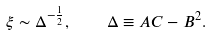<formula> <loc_0><loc_0><loc_500><loc_500>\xi \sim \Delta ^ { - \frac { 1 } { 2 } } , \quad \Delta \equiv A C - B ^ { 2 } .</formula> 